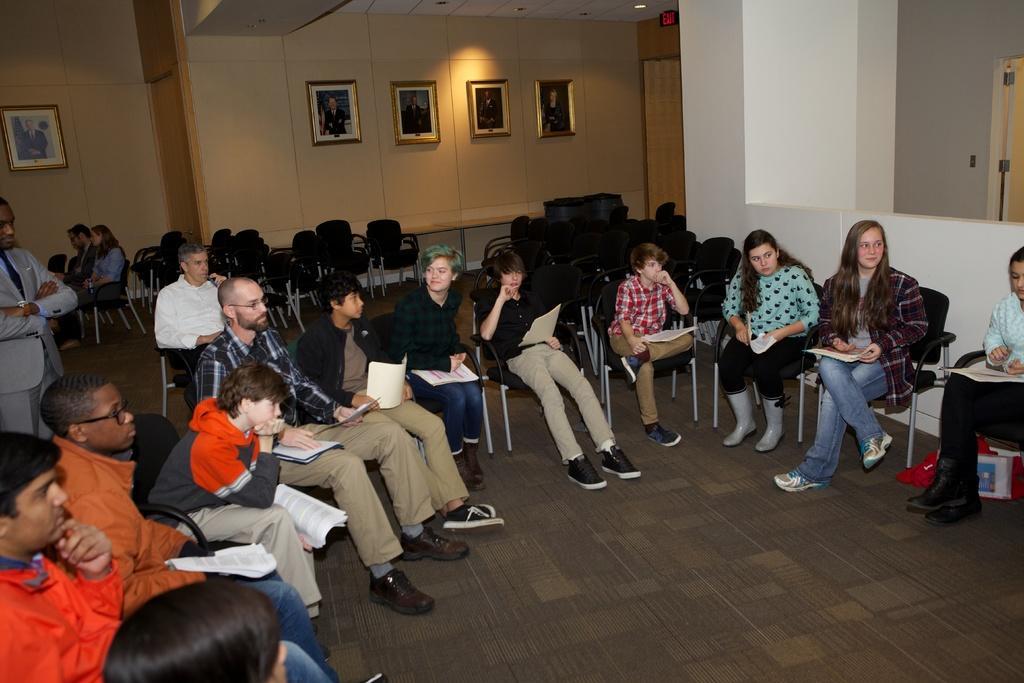Could you give a brief overview of what you see in this image? On the right there is a woman who is wearing blue shirt, trouser and shoe. She is sitting on the chair. Bottom of the chair we can see red plastic cover and papers. Beside her we can see another woman who is wearing jacket, trouser and shoe. She is also holding the papers. On the left there is a boy who is wearing hoodie, jeans and shoe. Sitting near to this bald man. In the background we can see photo frames on the wall. On the left background we can see group of persons sitting on the chair near to the wall. On the top right there is a door. Here we can see light and exit sign board. 